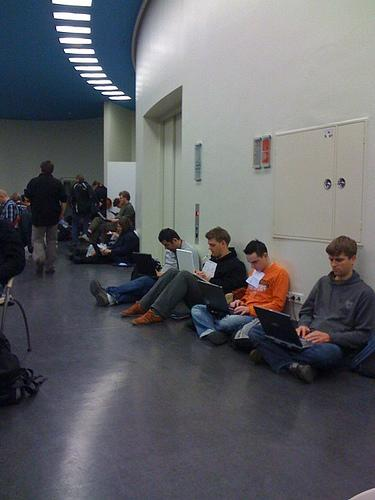What are the men against the wall working on? Please explain your reasoning. laptop. The men have laptops. 